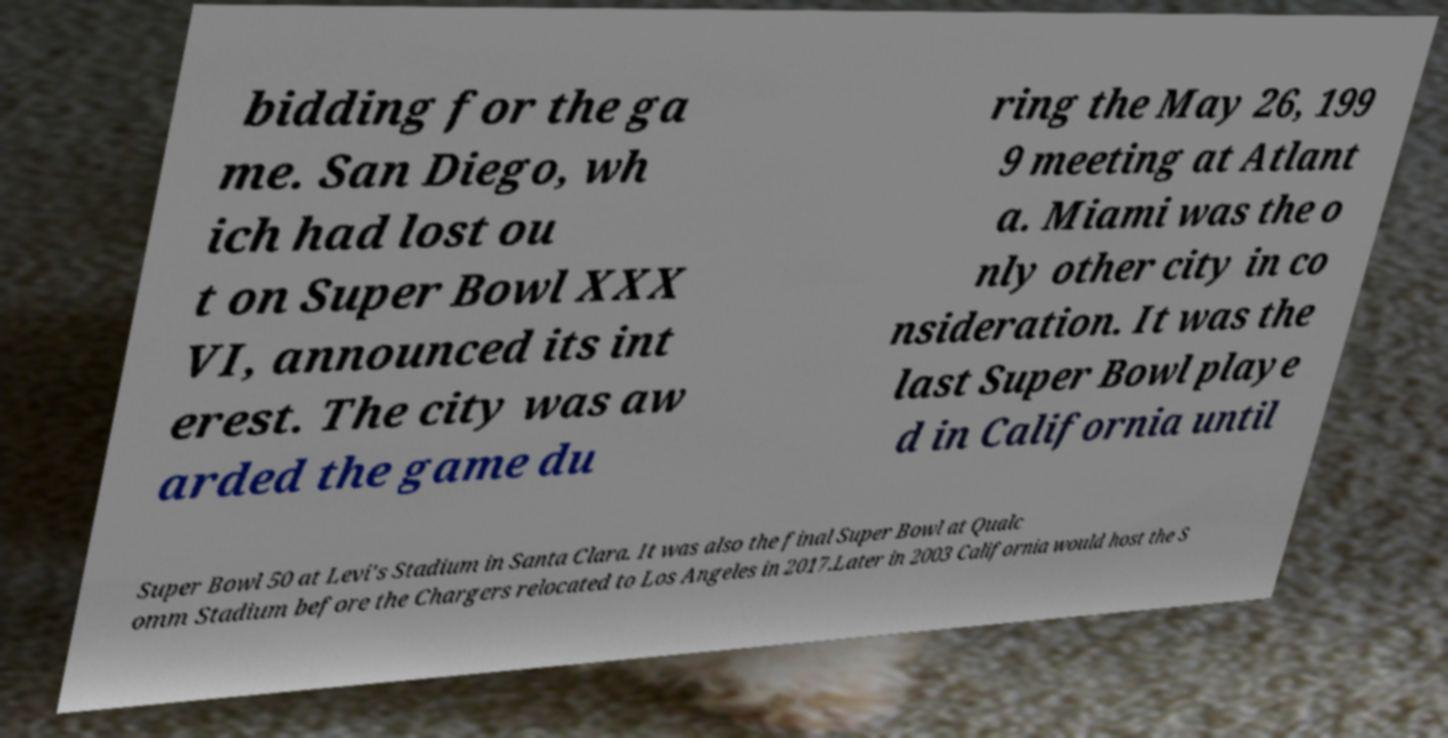What messages or text are displayed in this image? I need them in a readable, typed format. bidding for the ga me. San Diego, wh ich had lost ou t on Super Bowl XXX VI, announced its int erest. The city was aw arded the game du ring the May 26, 199 9 meeting at Atlant a. Miami was the o nly other city in co nsideration. It was the last Super Bowl playe d in California until Super Bowl 50 at Levi's Stadium in Santa Clara. It was also the final Super Bowl at Qualc omm Stadium before the Chargers relocated to Los Angeles in 2017.Later in 2003 California would host the S 